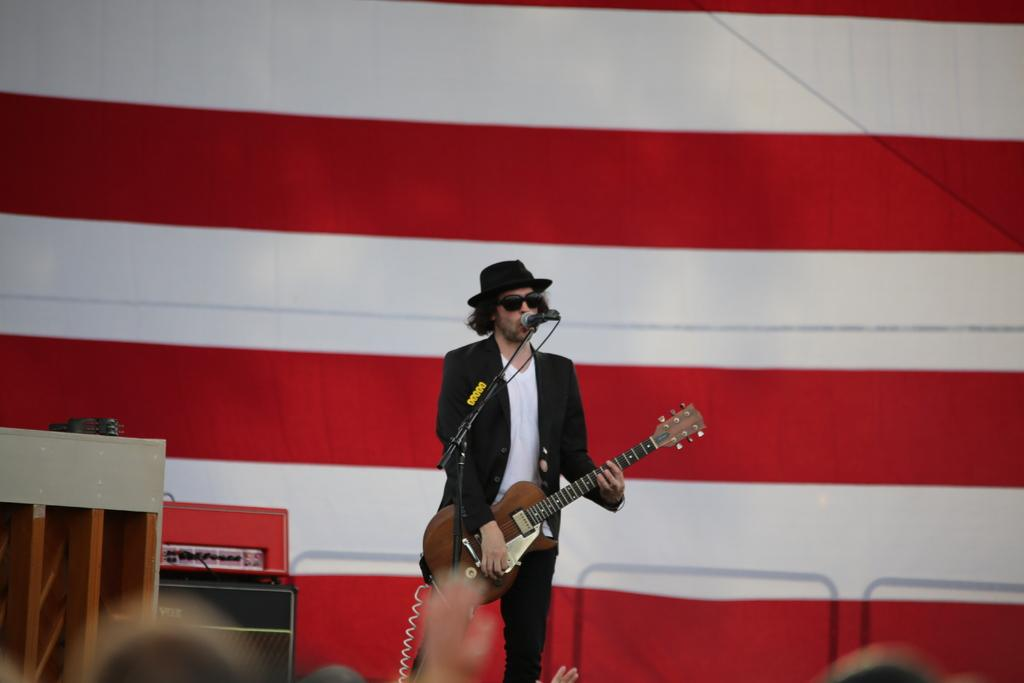What is the man in the image doing? The man is playing a guitar and standing in front of a microphone. What is the man wearing in the image? The man is wearing goggles. What can be seen in the background of the image? There is a cloth and a table in the background of the image. What type of muscle is being exercised by the man in the image? There is no indication in the image that the man is exercising any muscles, as he is playing a guitar and standing in front of a microphone. 